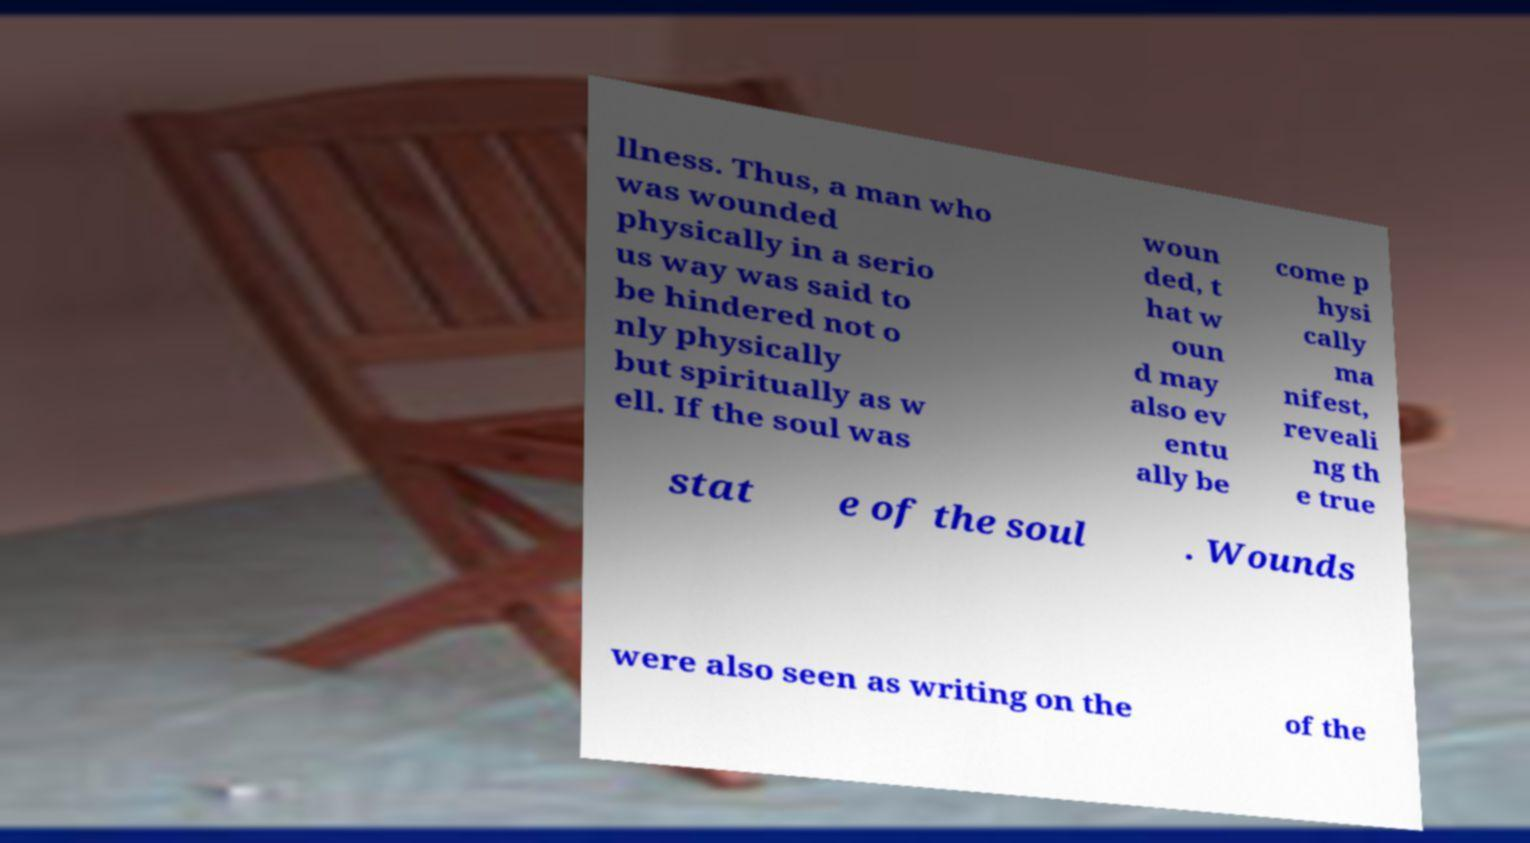Could you extract and type out the text from this image? llness. Thus, a man who was wounded physically in a serio us way was said to be hindered not o nly physically but spiritually as w ell. If the soul was woun ded, t hat w oun d may also ev entu ally be come p hysi cally ma nifest, reveali ng th e true stat e of the soul . Wounds were also seen as writing on the of the 